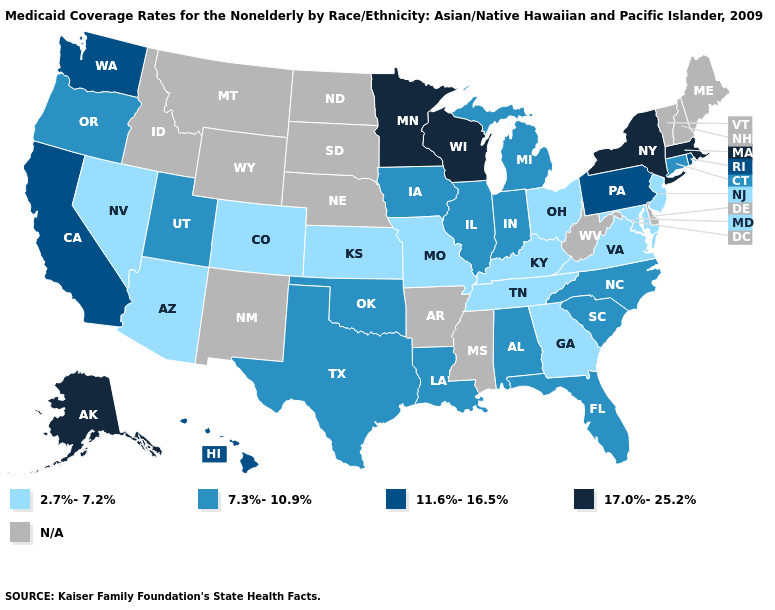Among the states that border Colorado , which have the lowest value?
Give a very brief answer. Arizona, Kansas. Among the states that border Oregon , does Washington have the highest value?
Be succinct. Yes. What is the value of Hawaii?
Short answer required. 11.6%-16.5%. Does Michigan have the lowest value in the MidWest?
Concise answer only. No. What is the value of Mississippi?
Answer briefly. N/A. Does Massachusetts have the highest value in the Northeast?
Answer briefly. Yes. What is the value of Vermont?
Write a very short answer. N/A. What is the value of Kentucky?
Answer briefly. 2.7%-7.2%. Does the first symbol in the legend represent the smallest category?
Keep it brief. Yes. Among the states that border Arkansas , which have the highest value?
Give a very brief answer. Louisiana, Oklahoma, Texas. What is the value of Oregon?
Answer briefly. 7.3%-10.9%. Which states have the lowest value in the MidWest?
Answer briefly. Kansas, Missouri, Ohio. Does the first symbol in the legend represent the smallest category?
Give a very brief answer. Yes. 